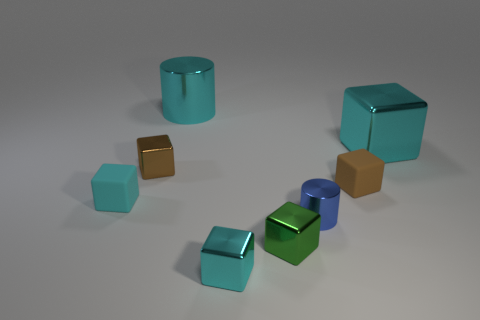Can you describe the arrangement of the objects and what sort of atmosphere or setting it might suggest? The objects are scattered seemingly haphazardly across a flat surface, with a sense of randomness. This arrangement suggests a casual or unplanned setting, perhaps as if someone had been experimenting with different shapes and left them as they were. 